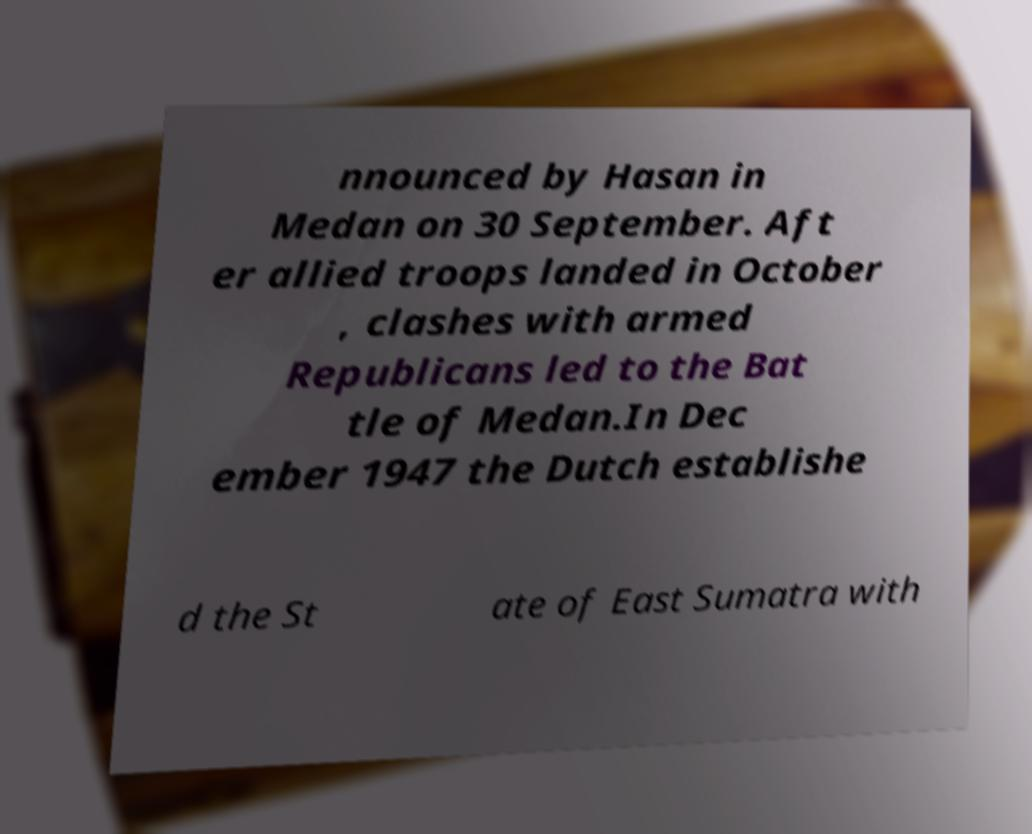I need the written content from this picture converted into text. Can you do that? nnounced by Hasan in Medan on 30 September. Aft er allied troops landed in October , clashes with armed Republicans led to the Bat tle of Medan.In Dec ember 1947 the Dutch establishe d the St ate of East Sumatra with 